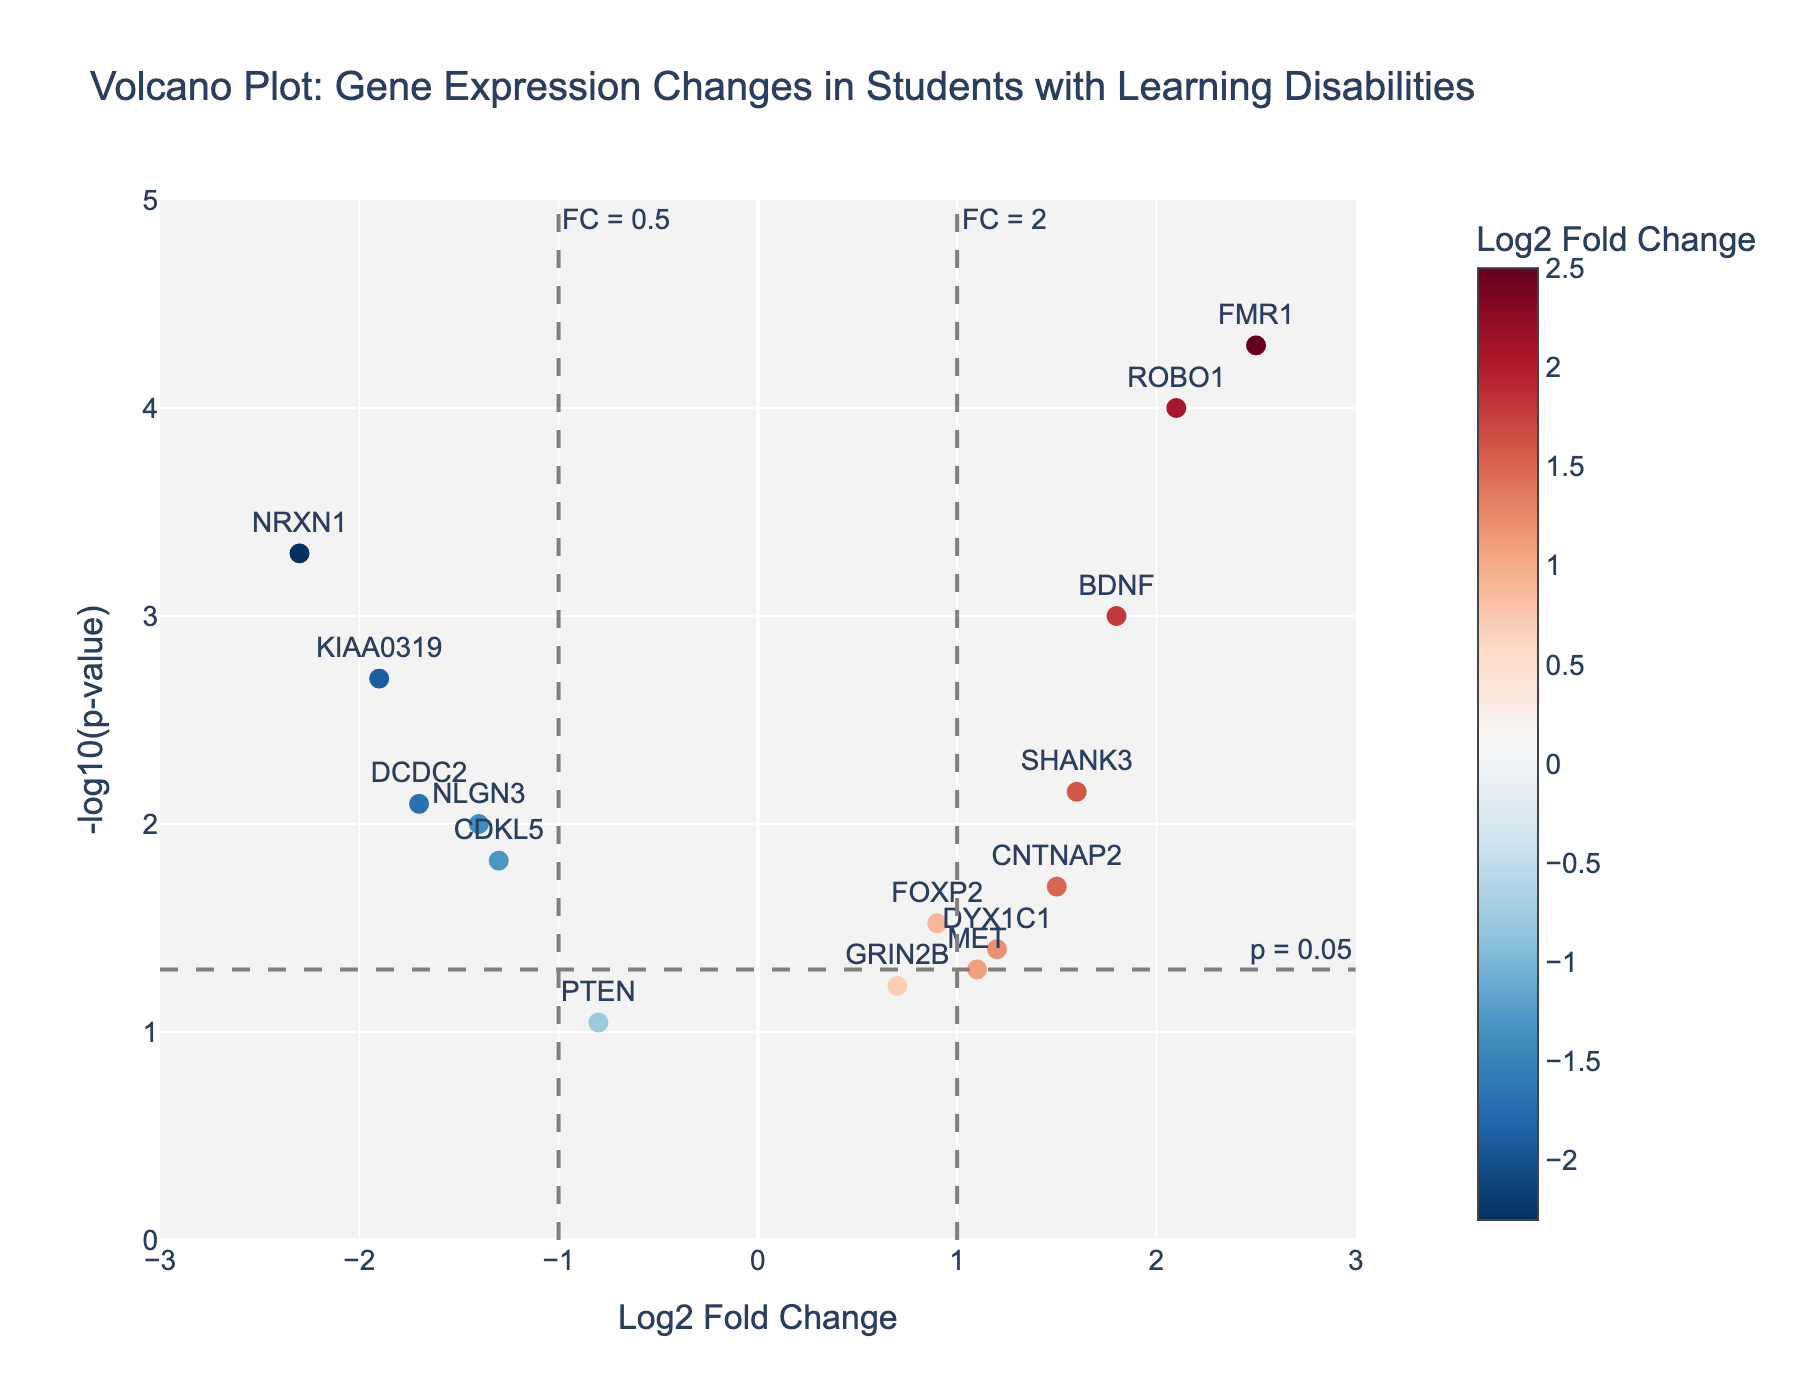How many genes are shown in the plot? Count the number of markers on the plot, which equals the number of genes. Here, a total of 15 markers are used, corresponding to 15 genes.
Answer: 15 What is the title of the plot? The title is typically placed at the top of the plot. Here, it reads "Volcano Plot: Gene Expression Changes in Students with Learning Disabilities."
Answer: Volcano Plot: Gene Expression Changes in Students with Learning Disabilities Which gene has the highest log2 fold change? Look for the point with the highest x-axis value as the log2 fold change is plotted on the x-axis. FMR1 has a log2 fold change of 2.5, the highest in the plot.
Answer: FMR1 What is the meaning of the dashed horizontal line at y = 1.3? This line represents the -log10(p-value) threshold for significance; p = 0.05 converts to -log10(0.05) which is approximately 1.3.
Answer: Significance threshold (p = 0.05) Which genes have a log2 fold change greater than 2? Identify points to the right of the vertical dashed line at x = 2 on the plot. Here, ROBO1 and FMR1 have log2 fold changes greater than 2.
Answer: ROBO1, FMR1 Which gene has the lowest p-value, and what is its value? Find the gene with the highest y-axis value because y = -log10(p-value); the highest point is FMR1, and its p-value is 0.00005.
Answer: FMR1, 0.00005 Which gene has a negative log2 fold change and is most statistically significant? Look for a gene on the left (negative x-axis) with the highest y-axis value. NRXN1 has a log2 fold change of -2.3 and a p-value of 0.0005 (very low).
Answer: NRXN1 How many genes have a log2 fold change between -1 and 1? Count all points between the vertical lines at x = -1 and x = 1. Here, BDNF, NRXN1, CNTNAP2, FOXP2, DCDC2, DYX1C1, KIAA0319, ROBO1, GRIN2B, NLGN3, SHANK3, PTEN, MET, and CDKL5 have log2 fold changes in this range. This gives 14 points.
Answer: 14 What color represents the highest log2 fold change values on the plot? The color bar on the right side of the plot indicates the color scale. The highest log2 fold change values are shown in red.
Answer: Red 